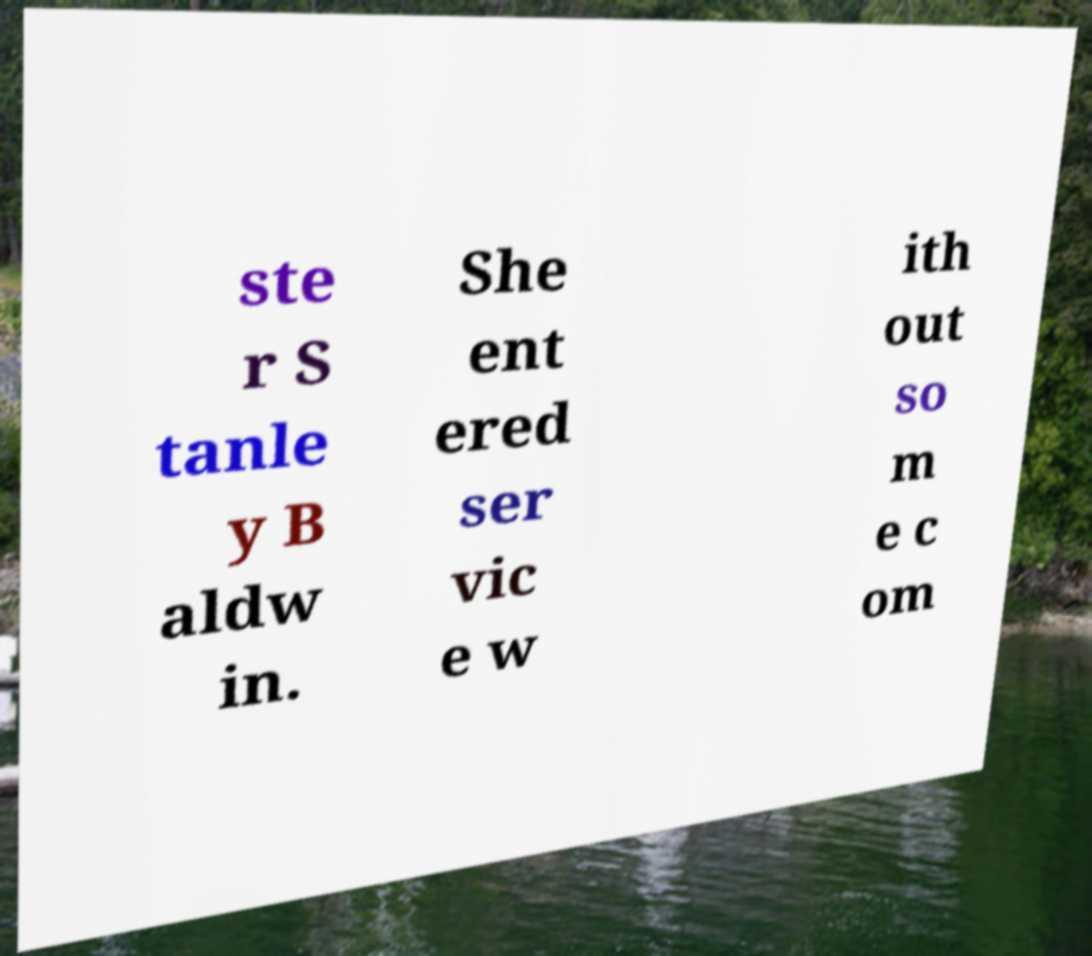Can you read and provide the text displayed in the image?This photo seems to have some interesting text. Can you extract and type it out for me? ste r S tanle y B aldw in. She ent ered ser vic e w ith out so m e c om 